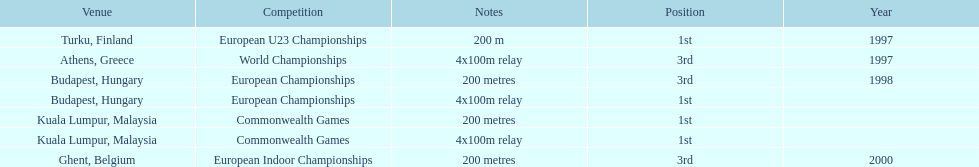In what year did england get the top achievment in the 200 meter? 1997. 